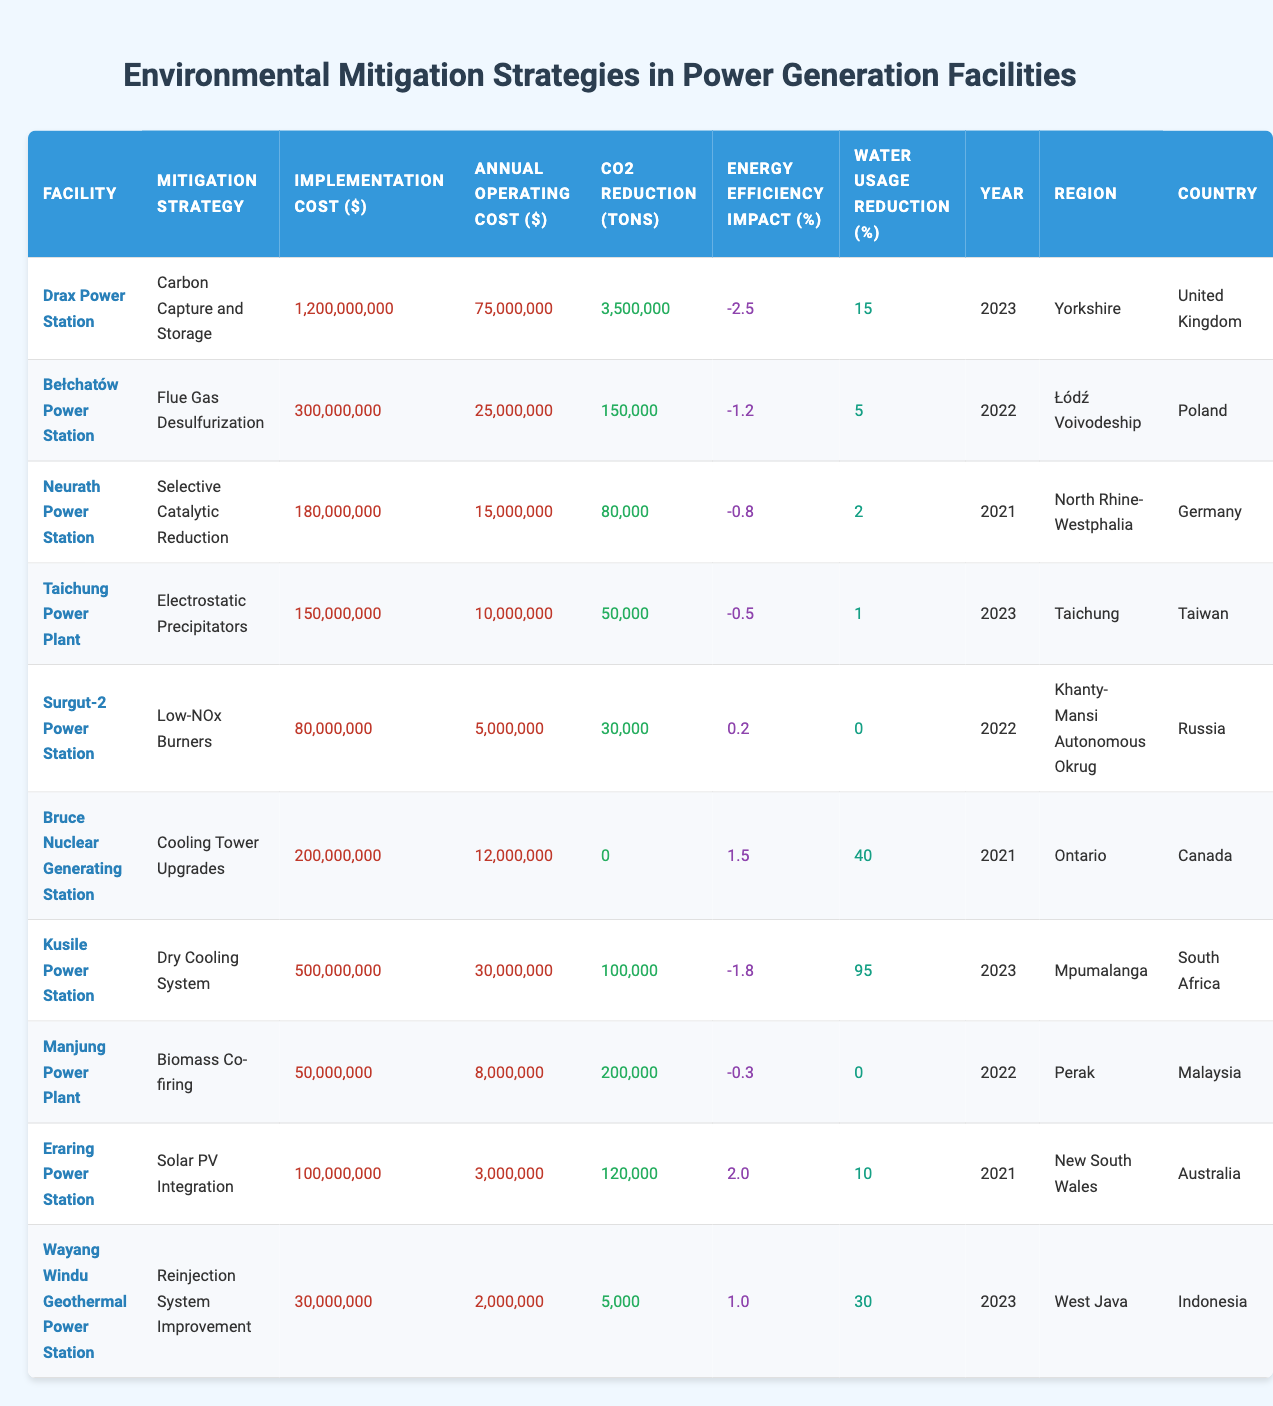What is the implementation cost of Drax Power Station's mitigation strategy? The implementation cost for Drax Power Station's mitigation strategy, Carbon Capture and Storage, is listed directly in the table. It states 1,200,000,000 dollars.
Answer: 1,200,000,000 Which mitigation strategy at Kusile Power Station has the highest water usage reduction percentage? Kusile Power Station uses the Dry Cooling System as its mitigation strategy, which has a water usage reduction of 95%. This value can be directly found in the table.
Answer: Dry Cooling System What was the annual operating cost of the Bruce Nuclear Generating Station? The table shows that the annual operating cost of Bruce Nuclear Generating Station for Cooling Tower Upgrades is 12,000,000 dollars.
Answer: 12,000,000 How many tons of CO2 were reduced by the mitigation strategies of the facilities listed in 2023? For the year 2023, the data lists two facilities: Drax Power Station (3,500,000 tons) and Taichung Power Plant (50,000 tons). Adding these together gives a total CO2 reduction of 3,550,000 tons (3,500,000 + 50,000).
Answer: 3,550,000 Is the energy efficiency impact of the Flue Gas Desulfurization strategy positive or negative? The energy efficiency impact for Flue Gas Desulfurization, implemented at Bełchatów Power Station, is -1.2 as shown in the table, indicating a negative impact.
Answer: Negative Which power station had the lowest implementation cost and what was it? The table shows that the Manjung Power Plant's mitigation strategy, Biomass Co-firing, has the lowest implementation cost at 50,000,000 dollars compared to other facilities.
Answer: 50,000,000 Which facility's mitigation strategy has no CO2 reduction but the highest water usage reduction? According to the table, the Bruce Nuclear Generating Station's Cooling Tower Upgrades shows a CO2 reduction of 0 tons while achieving a water usage reduction of 40%. This answers the question with both elements addressed.
Answer: Bruce Nuclear Generating Station What is the average annual operating cost for all facilities listed? To calculate the average annual operating cost, we sum the annual operating costs for each facility (75,000,000 + 25,000,000 + 15,000,000 + 10,000,000 + 5,000,000 + 12,000,000 + 30,000,000 + 8,000,000 + 3,000,000 + 2,000,000) =  265,000,000. There are 10 facilities listed, so the average annual operating cost is 265,000,000 / 10 = 26,500,000.
Answer: 26,500,000 What was the implementation cost for the Selective Catalytic Reduction strategy and which country is it located in? The implementation cost for the Selective Catalytic Reduction strategy at Neurath Power Station is 180,000,000 dollars, and it is located in Germany as displayed in the table.
Answer: 180,000,000, Germany 